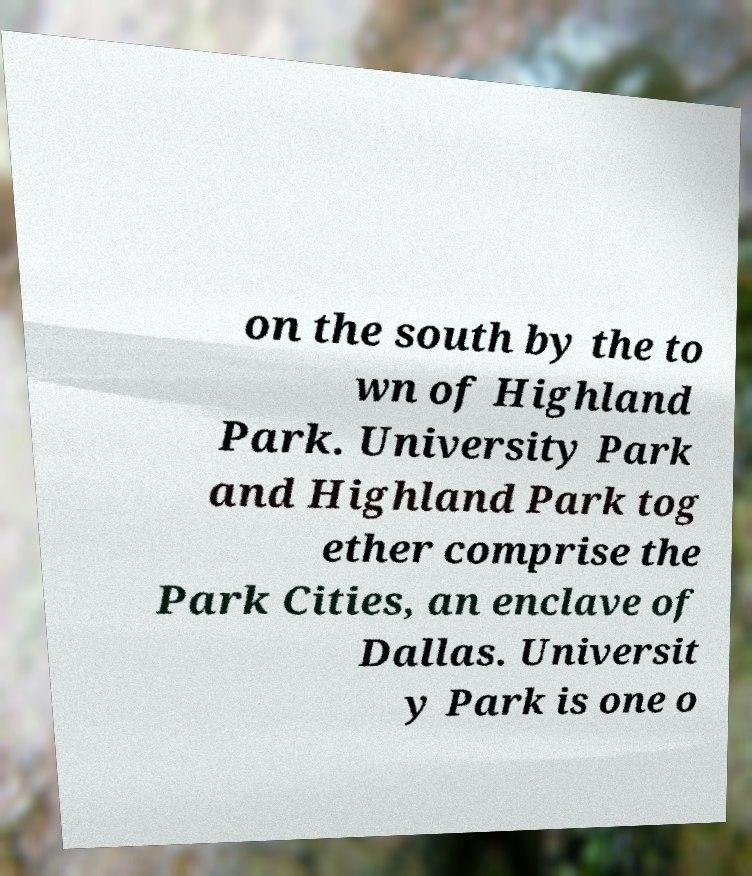There's text embedded in this image that I need extracted. Can you transcribe it verbatim? on the south by the to wn of Highland Park. University Park and Highland Park tog ether comprise the Park Cities, an enclave of Dallas. Universit y Park is one o 